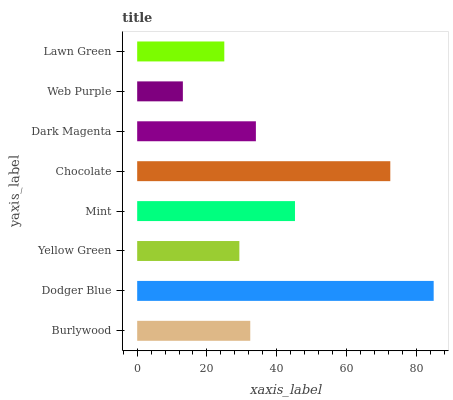Is Web Purple the minimum?
Answer yes or no. Yes. Is Dodger Blue the maximum?
Answer yes or no. Yes. Is Yellow Green the minimum?
Answer yes or no. No. Is Yellow Green the maximum?
Answer yes or no. No. Is Dodger Blue greater than Yellow Green?
Answer yes or no. Yes. Is Yellow Green less than Dodger Blue?
Answer yes or no. Yes. Is Yellow Green greater than Dodger Blue?
Answer yes or no. No. Is Dodger Blue less than Yellow Green?
Answer yes or no. No. Is Dark Magenta the high median?
Answer yes or no. Yes. Is Burlywood the low median?
Answer yes or no. Yes. Is Lawn Green the high median?
Answer yes or no. No. Is Mint the low median?
Answer yes or no. No. 